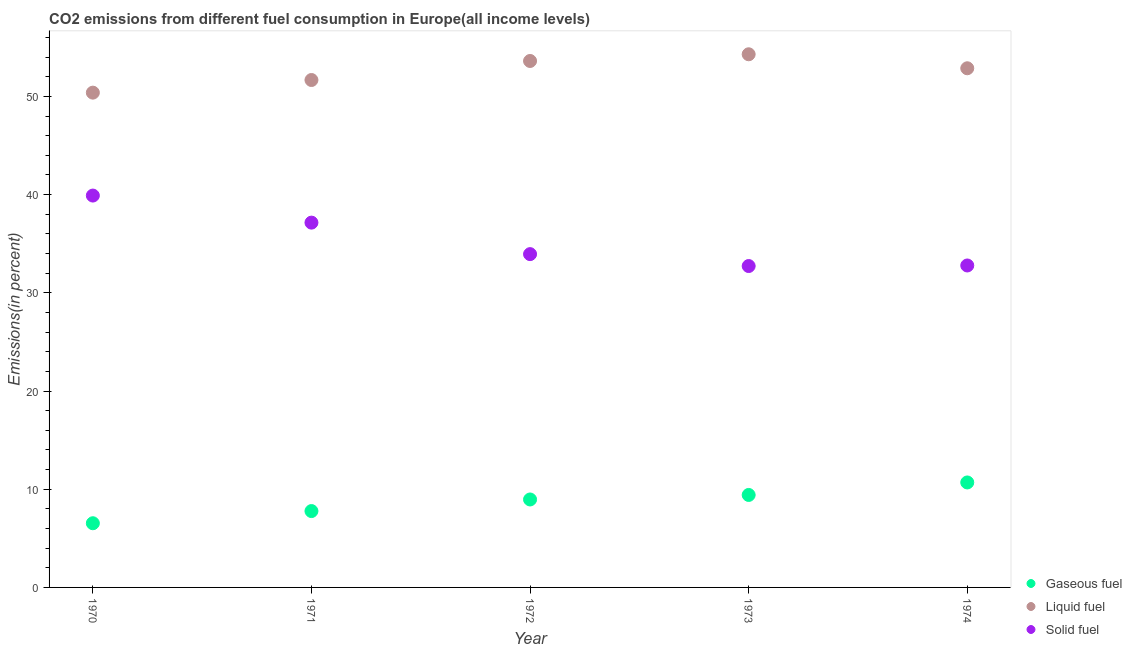Is the number of dotlines equal to the number of legend labels?
Ensure brevity in your answer.  Yes. What is the percentage of gaseous fuel emission in 1973?
Your answer should be compact. 9.42. Across all years, what is the maximum percentage of gaseous fuel emission?
Your answer should be very brief. 10.69. Across all years, what is the minimum percentage of solid fuel emission?
Keep it short and to the point. 32.73. In which year was the percentage of solid fuel emission minimum?
Your answer should be compact. 1973. What is the total percentage of liquid fuel emission in the graph?
Give a very brief answer. 262.83. What is the difference between the percentage of gaseous fuel emission in 1972 and that in 1973?
Offer a terse response. -0.46. What is the difference between the percentage of gaseous fuel emission in 1974 and the percentage of liquid fuel emission in 1973?
Offer a very short reply. -43.6. What is the average percentage of liquid fuel emission per year?
Offer a terse response. 52.57. In the year 1971, what is the difference between the percentage of solid fuel emission and percentage of gaseous fuel emission?
Ensure brevity in your answer.  29.37. What is the ratio of the percentage of solid fuel emission in 1971 to that in 1972?
Make the answer very short. 1.09. Is the difference between the percentage of gaseous fuel emission in 1973 and 1974 greater than the difference between the percentage of liquid fuel emission in 1973 and 1974?
Keep it short and to the point. No. What is the difference between the highest and the second highest percentage of liquid fuel emission?
Offer a very short reply. 0.68. What is the difference between the highest and the lowest percentage of gaseous fuel emission?
Your answer should be compact. 4.15. In how many years, is the percentage of gaseous fuel emission greater than the average percentage of gaseous fuel emission taken over all years?
Your answer should be very brief. 3. Does the percentage of liquid fuel emission monotonically increase over the years?
Offer a terse response. No. How many years are there in the graph?
Your response must be concise. 5. Does the graph contain grids?
Your answer should be compact. No. Where does the legend appear in the graph?
Give a very brief answer. Bottom right. How many legend labels are there?
Make the answer very short. 3. How are the legend labels stacked?
Your response must be concise. Vertical. What is the title of the graph?
Your answer should be very brief. CO2 emissions from different fuel consumption in Europe(all income levels). Does "Ages 50+" appear as one of the legend labels in the graph?
Make the answer very short. No. What is the label or title of the Y-axis?
Provide a succinct answer. Emissions(in percent). What is the Emissions(in percent) of Gaseous fuel in 1970?
Offer a very short reply. 6.54. What is the Emissions(in percent) of Liquid fuel in 1970?
Offer a terse response. 50.39. What is the Emissions(in percent) of Solid fuel in 1970?
Offer a very short reply. 39.91. What is the Emissions(in percent) in Gaseous fuel in 1971?
Make the answer very short. 7.78. What is the Emissions(in percent) of Liquid fuel in 1971?
Your answer should be compact. 51.67. What is the Emissions(in percent) in Solid fuel in 1971?
Your answer should be compact. 37.15. What is the Emissions(in percent) of Gaseous fuel in 1972?
Provide a short and direct response. 8.96. What is the Emissions(in percent) of Liquid fuel in 1972?
Give a very brief answer. 53.61. What is the Emissions(in percent) of Solid fuel in 1972?
Provide a short and direct response. 33.94. What is the Emissions(in percent) of Gaseous fuel in 1973?
Your answer should be very brief. 9.42. What is the Emissions(in percent) of Liquid fuel in 1973?
Offer a very short reply. 54.29. What is the Emissions(in percent) of Solid fuel in 1973?
Provide a short and direct response. 32.73. What is the Emissions(in percent) of Gaseous fuel in 1974?
Your answer should be compact. 10.69. What is the Emissions(in percent) in Liquid fuel in 1974?
Your response must be concise. 52.87. What is the Emissions(in percent) in Solid fuel in 1974?
Give a very brief answer. 32.79. Across all years, what is the maximum Emissions(in percent) of Gaseous fuel?
Give a very brief answer. 10.69. Across all years, what is the maximum Emissions(in percent) of Liquid fuel?
Your answer should be very brief. 54.29. Across all years, what is the maximum Emissions(in percent) in Solid fuel?
Offer a terse response. 39.91. Across all years, what is the minimum Emissions(in percent) of Gaseous fuel?
Offer a very short reply. 6.54. Across all years, what is the minimum Emissions(in percent) in Liquid fuel?
Offer a very short reply. 50.39. Across all years, what is the minimum Emissions(in percent) of Solid fuel?
Provide a succinct answer. 32.73. What is the total Emissions(in percent) of Gaseous fuel in the graph?
Your response must be concise. 43.38. What is the total Emissions(in percent) of Liquid fuel in the graph?
Keep it short and to the point. 262.83. What is the total Emissions(in percent) of Solid fuel in the graph?
Keep it short and to the point. 176.51. What is the difference between the Emissions(in percent) of Gaseous fuel in 1970 and that in 1971?
Your answer should be very brief. -1.24. What is the difference between the Emissions(in percent) of Liquid fuel in 1970 and that in 1971?
Make the answer very short. -1.29. What is the difference between the Emissions(in percent) of Solid fuel in 1970 and that in 1971?
Ensure brevity in your answer.  2.76. What is the difference between the Emissions(in percent) in Gaseous fuel in 1970 and that in 1972?
Give a very brief answer. -2.42. What is the difference between the Emissions(in percent) in Liquid fuel in 1970 and that in 1972?
Provide a succinct answer. -3.23. What is the difference between the Emissions(in percent) of Solid fuel in 1970 and that in 1972?
Your answer should be compact. 5.96. What is the difference between the Emissions(in percent) of Gaseous fuel in 1970 and that in 1973?
Offer a terse response. -2.88. What is the difference between the Emissions(in percent) in Liquid fuel in 1970 and that in 1973?
Keep it short and to the point. -3.91. What is the difference between the Emissions(in percent) in Solid fuel in 1970 and that in 1973?
Provide a short and direct response. 7.18. What is the difference between the Emissions(in percent) of Gaseous fuel in 1970 and that in 1974?
Your answer should be very brief. -4.15. What is the difference between the Emissions(in percent) of Liquid fuel in 1970 and that in 1974?
Make the answer very short. -2.48. What is the difference between the Emissions(in percent) in Solid fuel in 1970 and that in 1974?
Your answer should be compact. 7.12. What is the difference between the Emissions(in percent) of Gaseous fuel in 1971 and that in 1972?
Keep it short and to the point. -1.18. What is the difference between the Emissions(in percent) of Liquid fuel in 1971 and that in 1972?
Offer a terse response. -1.94. What is the difference between the Emissions(in percent) of Solid fuel in 1971 and that in 1972?
Give a very brief answer. 3.21. What is the difference between the Emissions(in percent) of Gaseous fuel in 1971 and that in 1973?
Keep it short and to the point. -1.64. What is the difference between the Emissions(in percent) in Liquid fuel in 1971 and that in 1973?
Provide a short and direct response. -2.62. What is the difference between the Emissions(in percent) in Solid fuel in 1971 and that in 1973?
Your answer should be very brief. 4.42. What is the difference between the Emissions(in percent) in Gaseous fuel in 1971 and that in 1974?
Keep it short and to the point. -2.91. What is the difference between the Emissions(in percent) in Liquid fuel in 1971 and that in 1974?
Provide a short and direct response. -1.2. What is the difference between the Emissions(in percent) in Solid fuel in 1971 and that in 1974?
Offer a very short reply. 4.36. What is the difference between the Emissions(in percent) of Gaseous fuel in 1972 and that in 1973?
Give a very brief answer. -0.46. What is the difference between the Emissions(in percent) in Liquid fuel in 1972 and that in 1973?
Make the answer very short. -0.68. What is the difference between the Emissions(in percent) of Solid fuel in 1972 and that in 1973?
Your answer should be compact. 1.21. What is the difference between the Emissions(in percent) of Gaseous fuel in 1972 and that in 1974?
Ensure brevity in your answer.  -1.73. What is the difference between the Emissions(in percent) in Liquid fuel in 1972 and that in 1974?
Offer a very short reply. 0.74. What is the difference between the Emissions(in percent) in Solid fuel in 1972 and that in 1974?
Make the answer very short. 1.16. What is the difference between the Emissions(in percent) of Gaseous fuel in 1973 and that in 1974?
Your answer should be compact. -1.27. What is the difference between the Emissions(in percent) in Liquid fuel in 1973 and that in 1974?
Your response must be concise. 1.43. What is the difference between the Emissions(in percent) of Solid fuel in 1973 and that in 1974?
Your answer should be compact. -0.06. What is the difference between the Emissions(in percent) of Gaseous fuel in 1970 and the Emissions(in percent) of Liquid fuel in 1971?
Keep it short and to the point. -45.14. What is the difference between the Emissions(in percent) in Gaseous fuel in 1970 and the Emissions(in percent) in Solid fuel in 1971?
Ensure brevity in your answer.  -30.61. What is the difference between the Emissions(in percent) in Liquid fuel in 1970 and the Emissions(in percent) in Solid fuel in 1971?
Offer a terse response. 13.24. What is the difference between the Emissions(in percent) in Gaseous fuel in 1970 and the Emissions(in percent) in Liquid fuel in 1972?
Offer a very short reply. -47.07. What is the difference between the Emissions(in percent) of Gaseous fuel in 1970 and the Emissions(in percent) of Solid fuel in 1972?
Provide a succinct answer. -27.41. What is the difference between the Emissions(in percent) in Liquid fuel in 1970 and the Emissions(in percent) in Solid fuel in 1972?
Your answer should be compact. 16.44. What is the difference between the Emissions(in percent) of Gaseous fuel in 1970 and the Emissions(in percent) of Liquid fuel in 1973?
Give a very brief answer. -47.76. What is the difference between the Emissions(in percent) of Gaseous fuel in 1970 and the Emissions(in percent) of Solid fuel in 1973?
Make the answer very short. -26.19. What is the difference between the Emissions(in percent) in Liquid fuel in 1970 and the Emissions(in percent) in Solid fuel in 1973?
Give a very brief answer. 17.66. What is the difference between the Emissions(in percent) in Gaseous fuel in 1970 and the Emissions(in percent) in Liquid fuel in 1974?
Provide a succinct answer. -46.33. What is the difference between the Emissions(in percent) in Gaseous fuel in 1970 and the Emissions(in percent) in Solid fuel in 1974?
Offer a very short reply. -26.25. What is the difference between the Emissions(in percent) of Liquid fuel in 1970 and the Emissions(in percent) of Solid fuel in 1974?
Provide a short and direct response. 17.6. What is the difference between the Emissions(in percent) in Gaseous fuel in 1971 and the Emissions(in percent) in Liquid fuel in 1972?
Offer a very short reply. -45.84. What is the difference between the Emissions(in percent) of Gaseous fuel in 1971 and the Emissions(in percent) of Solid fuel in 1972?
Give a very brief answer. -26.17. What is the difference between the Emissions(in percent) of Liquid fuel in 1971 and the Emissions(in percent) of Solid fuel in 1972?
Ensure brevity in your answer.  17.73. What is the difference between the Emissions(in percent) of Gaseous fuel in 1971 and the Emissions(in percent) of Liquid fuel in 1973?
Your answer should be compact. -46.52. What is the difference between the Emissions(in percent) of Gaseous fuel in 1971 and the Emissions(in percent) of Solid fuel in 1973?
Make the answer very short. -24.95. What is the difference between the Emissions(in percent) of Liquid fuel in 1971 and the Emissions(in percent) of Solid fuel in 1973?
Your answer should be very brief. 18.94. What is the difference between the Emissions(in percent) in Gaseous fuel in 1971 and the Emissions(in percent) in Liquid fuel in 1974?
Ensure brevity in your answer.  -45.09. What is the difference between the Emissions(in percent) of Gaseous fuel in 1971 and the Emissions(in percent) of Solid fuel in 1974?
Your answer should be compact. -25.01. What is the difference between the Emissions(in percent) of Liquid fuel in 1971 and the Emissions(in percent) of Solid fuel in 1974?
Give a very brief answer. 18.89. What is the difference between the Emissions(in percent) of Gaseous fuel in 1972 and the Emissions(in percent) of Liquid fuel in 1973?
Make the answer very short. -45.34. What is the difference between the Emissions(in percent) of Gaseous fuel in 1972 and the Emissions(in percent) of Solid fuel in 1973?
Your answer should be compact. -23.77. What is the difference between the Emissions(in percent) in Liquid fuel in 1972 and the Emissions(in percent) in Solid fuel in 1973?
Offer a terse response. 20.88. What is the difference between the Emissions(in percent) of Gaseous fuel in 1972 and the Emissions(in percent) of Liquid fuel in 1974?
Offer a terse response. -43.91. What is the difference between the Emissions(in percent) of Gaseous fuel in 1972 and the Emissions(in percent) of Solid fuel in 1974?
Your response must be concise. -23.83. What is the difference between the Emissions(in percent) in Liquid fuel in 1972 and the Emissions(in percent) in Solid fuel in 1974?
Offer a terse response. 20.83. What is the difference between the Emissions(in percent) in Gaseous fuel in 1973 and the Emissions(in percent) in Liquid fuel in 1974?
Offer a terse response. -43.45. What is the difference between the Emissions(in percent) of Gaseous fuel in 1973 and the Emissions(in percent) of Solid fuel in 1974?
Ensure brevity in your answer.  -23.37. What is the difference between the Emissions(in percent) in Liquid fuel in 1973 and the Emissions(in percent) in Solid fuel in 1974?
Make the answer very short. 21.51. What is the average Emissions(in percent) of Gaseous fuel per year?
Your answer should be compact. 8.68. What is the average Emissions(in percent) of Liquid fuel per year?
Your answer should be very brief. 52.57. What is the average Emissions(in percent) in Solid fuel per year?
Your answer should be compact. 35.3. In the year 1970, what is the difference between the Emissions(in percent) in Gaseous fuel and Emissions(in percent) in Liquid fuel?
Make the answer very short. -43.85. In the year 1970, what is the difference between the Emissions(in percent) of Gaseous fuel and Emissions(in percent) of Solid fuel?
Offer a terse response. -33.37. In the year 1970, what is the difference between the Emissions(in percent) of Liquid fuel and Emissions(in percent) of Solid fuel?
Your answer should be very brief. 10.48. In the year 1971, what is the difference between the Emissions(in percent) of Gaseous fuel and Emissions(in percent) of Liquid fuel?
Make the answer very short. -43.9. In the year 1971, what is the difference between the Emissions(in percent) in Gaseous fuel and Emissions(in percent) in Solid fuel?
Offer a very short reply. -29.37. In the year 1971, what is the difference between the Emissions(in percent) of Liquid fuel and Emissions(in percent) of Solid fuel?
Give a very brief answer. 14.52. In the year 1972, what is the difference between the Emissions(in percent) of Gaseous fuel and Emissions(in percent) of Liquid fuel?
Your answer should be compact. -44.65. In the year 1972, what is the difference between the Emissions(in percent) of Gaseous fuel and Emissions(in percent) of Solid fuel?
Provide a short and direct response. -24.98. In the year 1972, what is the difference between the Emissions(in percent) in Liquid fuel and Emissions(in percent) in Solid fuel?
Your response must be concise. 19.67. In the year 1973, what is the difference between the Emissions(in percent) of Gaseous fuel and Emissions(in percent) of Liquid fuel?
Make the answer very short. -44.88. In the year 1973, what is the difference between the Emissions(in percent) of Gaseous fuel and Emissions(in percent) of Solid fuel?
Offer a terse response. -23.31. In the year 1973, what is the difference between the Emissions(in percent) of Liquid fuel and Emissions(in percent) of Solid fuel?
Ensure brevity in your answer.  21.57. In the year 1974, what is the difference between the Emissions(in percent) of Gaseous fuel and Emissions(in percent) of Liquid fuel?
Give a very brief answer. -42.18. In the year 1974, what is the difference between the Emissions(in percent) of Gaseous fuel and Emissions(in percent) of Solid fuel?
Your answer should be compact. -22.1. In the year 1974, what is the difference between the Emissions(in percent) of Liquid fuel and Emissions(in percent) of Solid fuel?
Offer a terse response. 20.08. What is the ratio of the Emissions(in percent) in Gaseous fuel in 1970 to that in 1971?
Offer a very short reply. 0.84. What is the ratio of the Emissions(in percent) of Liquid fuel in 1970 to that in 1971?
Ensure brevity in your answer.  0.98. What is the ratio of the Emissions(in percent) of Solid fuel in 1970 to that in 1971?
Keep it short and to the point. 1.07. What is the ratio of the Emissions(in percent) of Gaseous fuel in 1970 to that in 1972?
Ensure brevity in your answer.  0.73. What is the ratio of the Emissions(in percent) of Liquid fuel in 1970 to that in 1972?
Your answer should be very brief. 0.94. What is the ratio of the Emissions(in percent) of Solid fuel in 1970 to that in 1972?
Provide a succinct answer. 1.18. What is the ratio of the Emissions(in percent) of Gaseous fuel in 1970 to that in 1973?
Keep it short and to the point. 0.69. What is the ratio of the Emissions(in percent) of Liquid fuel in 1970 to that in 1973?
Keep it short and to the point. 0.93. What is the ratio of the Emissions(in percent) in Solid fuel in 1970 to that in 1973?
Offer a very short reply. 1.22. What is the ratio of the Emissions(in percent) of Gaseous fuel in 1970 to that in 1974?
Make the answer very short. 0.61. What is the ratio of the Emissions(in percent) in Liquid fuel in 1970 to that in 1974?
Offer a terse response. 0.95. What is the ratio of the Emissions(in percent) in Solid fuel in 1970 to that in 1974?
Make the answer very short. 1.22. What is the ratio of the Emissions(in percent) in Gaseous fuel in 1971 to that in 1972?
Your response must be concise. 0.87. What is the ratio of the Emissions(in percent) of Liquid fuel in 1971 to that in 1972?
Keep it short and to the point. 0.96. What is the ratio of the Emissions(in percent) in Solid fuel in 1971 to that in 1972?
Offer a very short reply. 1.09. What is the ratio of the Emissions(in percent) in Gaseous fuel in 1971 to that in 1973?
Your response must be concise. 0.83. What is the ratio of the Emissions(in percent) of Liquid fuel in 1971 to that in 1973?
Make the answer very short. 0.95. What is the ratio of the Emissions(in percent) in Solid fuel in 1971 to that in 1973?
Provide a short and direct response. 1.14. What is the ratio of the Emissions(in percent) in Gaseous fuel in 1971 to that in 1974?
Offer a very short reply. 0.73. What is the ratio of the Emissions(in percent) of Liquid fuel in 1971 to that in 1974?
Provide a succinct answer. 0.98. What is the ratio of the Emissions(in percent) in Solid fuel in 1971 to that in 1974?
Your answer should be compact. 1.13. What is the ratio of the Emissions(in percent) of Gaseous fuel in 1972 to that in 1973?
Provide a succinct answer. 0.95. What is the ratio of the Emissions(in percent) of Liquid fuel in 1972 to that in 1973?
Your answer should be compact. 0.99. What is the ratio of the Emissions(in percent) in Solid fuel in 1972 to that in 1973?
Offer a terse response. 1.04. What is the ratio of the Emissions(in percent) in Gaseous fuel in 1972 to that in 1974?
Offer a very short reply. 0.84. What is the ratio of the Emissions(in percent) in Liquid fuel in 1972 to that in 1974?
Your answer should be compact. 1.01. What is the ratio of the Emissions(in percent) of Solid fuel in 1972 to that in 1974?
Make the answer very short. 1.04. What is the ratio of the Emissions(in percent) of Gaseous fuel in 1973 to that in 1974?
Your response must be concise. 0.88. What is the ratio of the Emissions(in percent) in Liquid fuel in 1973 to that in 1974?
Offer a very short reply. 1.03. What is the ratio of the Emissions(in percent) in Solid fuel in 1973 to that in 1974?
Give a very brief answer. 1. What is the difference between the highest and the second highest Emissions(in percent) of Gaseous fuel?
Provide a short and direct response. 1.27. What is the difference between the highest and the second highest Emissions(in percent) in Liquid fuel?
Keep it short and to the point. 0.68. What is the difference between the highest and the second highest Emissions(in percent) of Solid fuel?
Offer a very short reply. 2.76. What is the difference between the highest and the lowest Emissions(in percent) in Gaseous fuel?
Your answer should be very brief. 4.15. What is the difference between the highest and the lowest Emissions(in percent) of Liquid fuel?
Your answer should be compact. 3.91. What is the difference between the highest and the lowest Emissions(in percent) in Solid fuel?
Your answer should be compact. 7.18. 